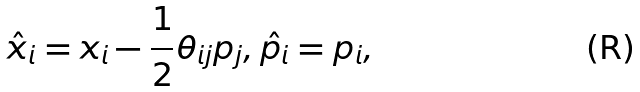Convert formula to latex. <formula><loc_0><loc_0><loc_500><loc_500>\hat { x } _ { i } = x _ { i } - \frac { 1 } { 2 } \theta _ { i j } p _ { j } , \hat { p _ { i } } = p _ { i } ,</formula> 